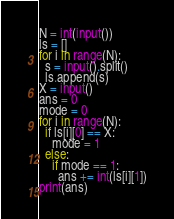<code> <loc_0><loc_0><loc_500><loc_500><_Python_>N = int(input())
ls = []
for i in range(N):
  s = input().split()
  ls.append(s)
X = input()
ans = 0
mode = 0
for i in range(N):
  if ls[i][0] == X:
    mode = 1
  else:
    if mode == 1:
      ans += int(ls[i][1])
print(ans)</code> 